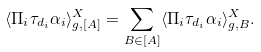<formula> <loc_0><loc_0><loc_500><loc_500>\langle \Pi _ { i } \tau _ { d _ { i } } \alpha _ { i } \rangle ^ { X } _ { g , [ A ] } = \sum _ { B \in [ A ] } \langle \Pi _ { i } \tau _ { d _ { i } } \alpha _ { i } \rangle ^ { X } _ { g , B } .</formula> 